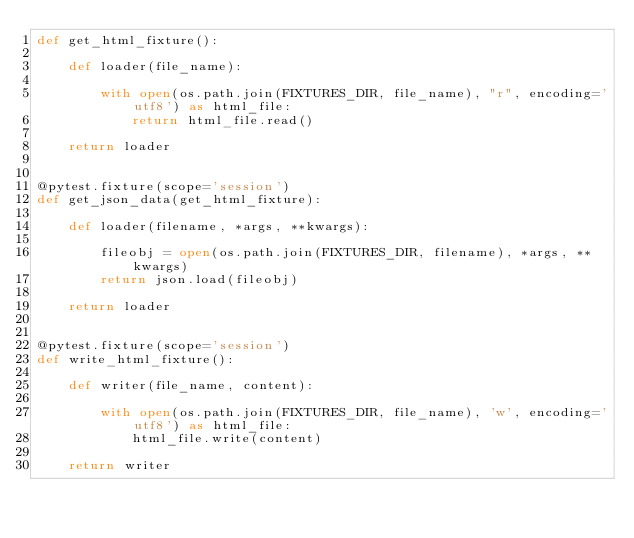Convert code to text. <code><loc_0><loc_0><loc_500><loc_500><_Python_>def get_html_fixture():

    def loader(file_name):

        with open(os.path.join(FIXTURES_DIR, file_name), "r", encoding='utf8') as html_file:
            return html_file.read()

    return loader


@pytest.fixture(scope='session')
def get_json_data(get_html_fixture):

    def loader(filename, *args, **kwargs):

        fileobj = open(os.path.join(FIXTURES_DIR, filename), *args, **kwargs)
        return json.load(fileobj)

    return loader


@pytest.fixture(scope='session')
def write_html_fixture():

    def writer(file_name, content):

        with open(os.path.join(FIXTURES_DIR, file_name), 'w', encoding='utf8') as html_file:
            html_file.write(content)

    return writer
</code> 